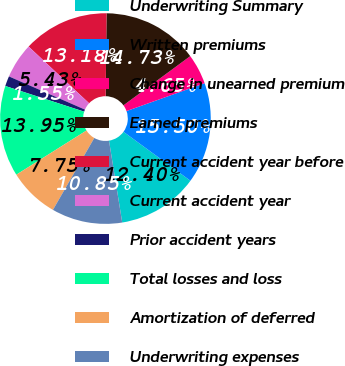<chart> <loc_0><loc_0><loc_500><loc_500><pie_chart><fcel>Underwriting Summary<fcel>Written premiums<fcel>Change in unearned premium<fcel>Earned premiums<fcel>Current accident year before<fcel>Current accident year<fcel>Prior accident years<fcel>Total losses and loss<fcel>Amortization of deferred<fcel>Underwriting expenses<nl><fcel>12.4%<fcel>15.5%<fcel>4.65%<fcel>14.73%<fcel>13.18%<fcel>5.43%<fcel>1.55%<fcel>13.95%<fcel>7.75%<fcel>10.85%<nl></chart> 